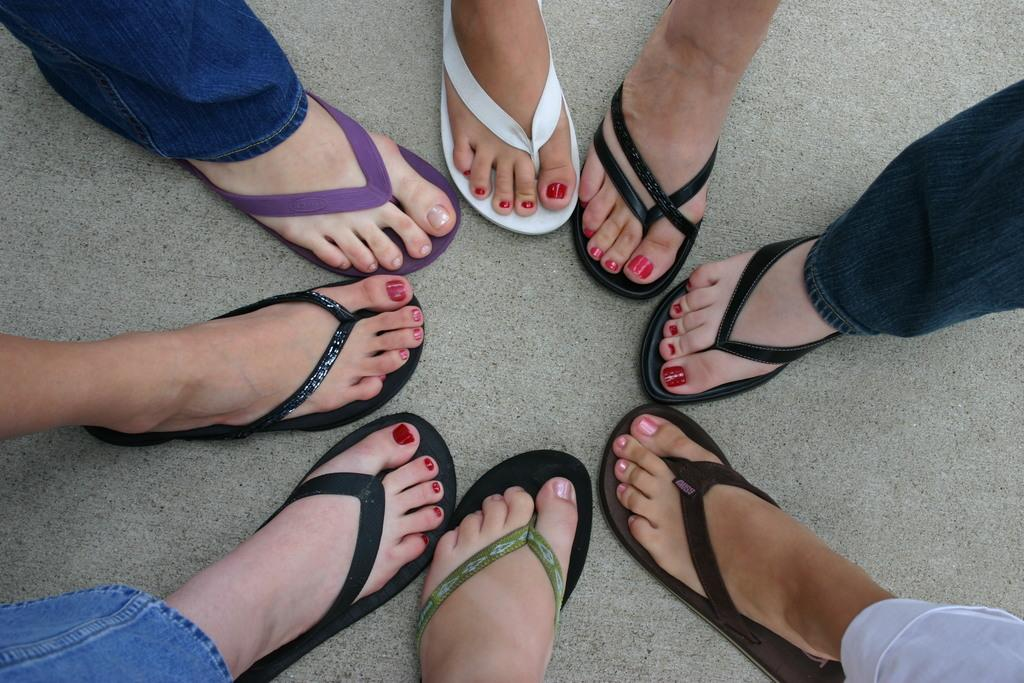How many people are in the image? There are persons in the image, but the exact number is not specified. What type of footwear are the persons wearing? The persons are wearing flip flops. Are the flip flops all the same or do they differ? The flip flops come in different types. Can you tell me how many lakes are visible in the image? There is no lake present in the image; it features persons wearing flip flops. Is there a team of people participating in a sport in the image? There is no indication of a team or any sporting activity in the image. 